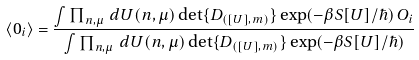<formula> <loc_0><loc_0><loc_500><loc_500>\langle 0 _ { i } \rangle = \frac { \int \prod _ { n , \mu } \, d U ( n , \mu ) \det \{ D _ { ( [ U ] , m ) } \} \exp ( - \beta S [ U ] / \hbar { ) } \, O _ { i } } { \int \prod _ { n , \mu } \, d U ( n , \mu ) \det \{ D _ { ( [ U ] , m ) } \} \exp ( - \beta S [ U ] / \hbar { ) } }</formula> 